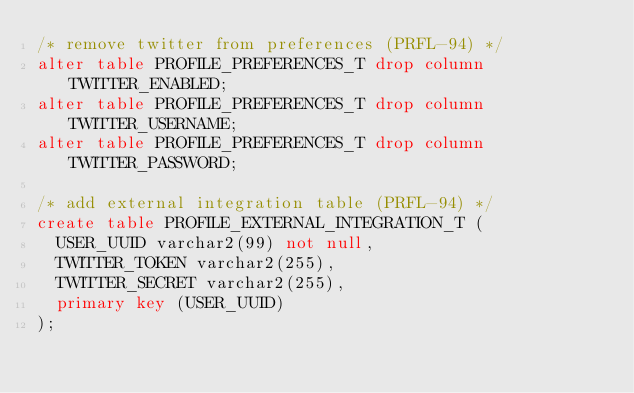Convert code to text. <code><loc_0><loc_0><loc_500><loc_500><_SQL_>/* remove twitter from preferences (PRFL-94) */
alter table PROFILE_PREFERENCES_T drop column TWITTER_ENABLED;
alter table PROFILE_PREFERENCES_T drop column TWITTER_USERNAME;
alter table PROFILE_PREFERENCES_T drop column TWITTER_PASSWORD;

/* add external integration table (PRFL-94) */
create table PROFILE_EXTERNAL_INTEGRATION_T (
	USER_UUID varchar2(99) not null,
	TWITTER_TOKEN varchar2(255),
	TWITTER_SECRET varchar2(255),
	primary key (USER_UUID)
);
</code> 